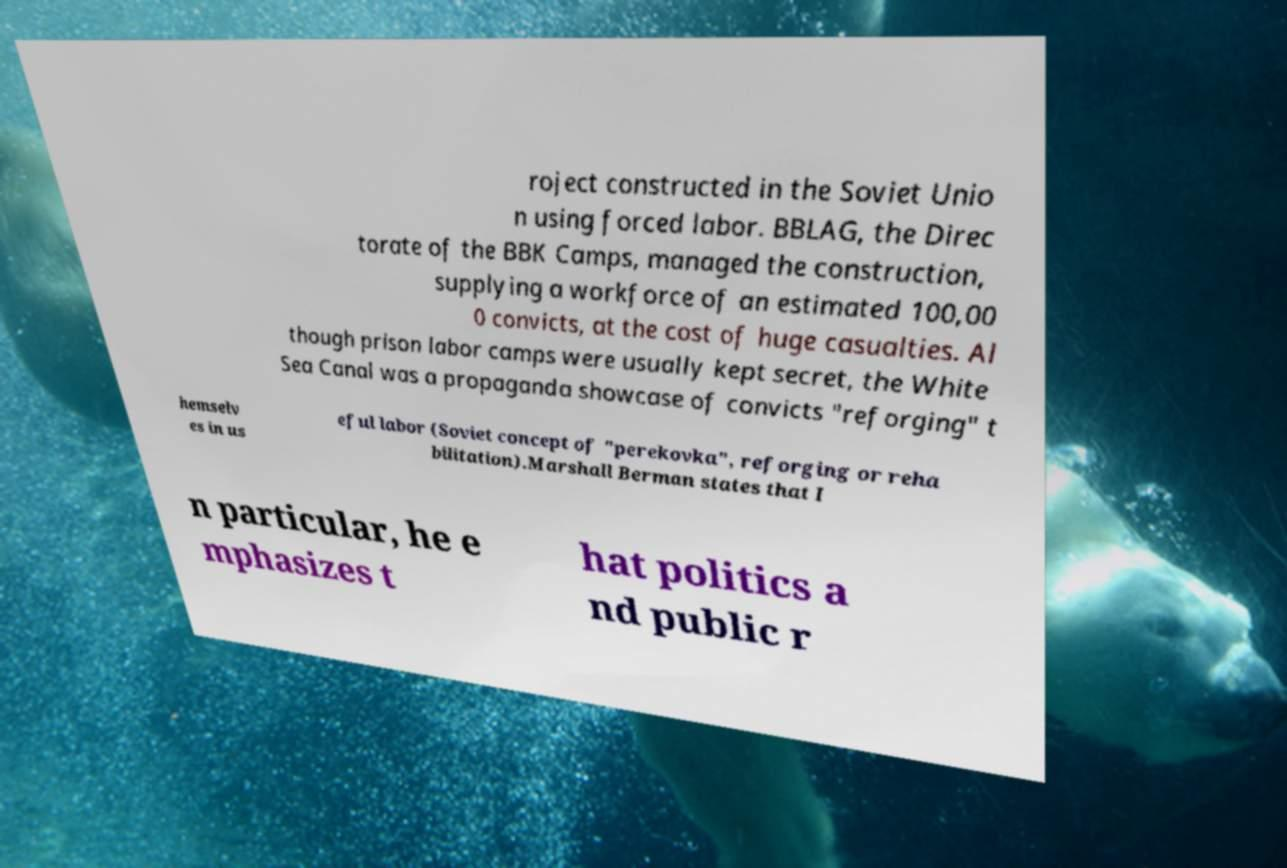Could you extract and type out the text from this image? roject constructed in the Soviet Unio n using forced labor. BBLAG, the Direc torate of the BBK Camps, managed the construction, supplying a workforce of an estimated 100,00 0 convicts, at the cost of huge casualties. Al though prison labor camps were usually kept secret, the White Sea Canal was a propaganda showcase of convicts "reforging" t hemselv es in us eful labor (Soviet concept of "perekovka", reforging or reha bilitation).Marshall Berman states that I n particular, he e mphasizes t hat politics a nd public r 